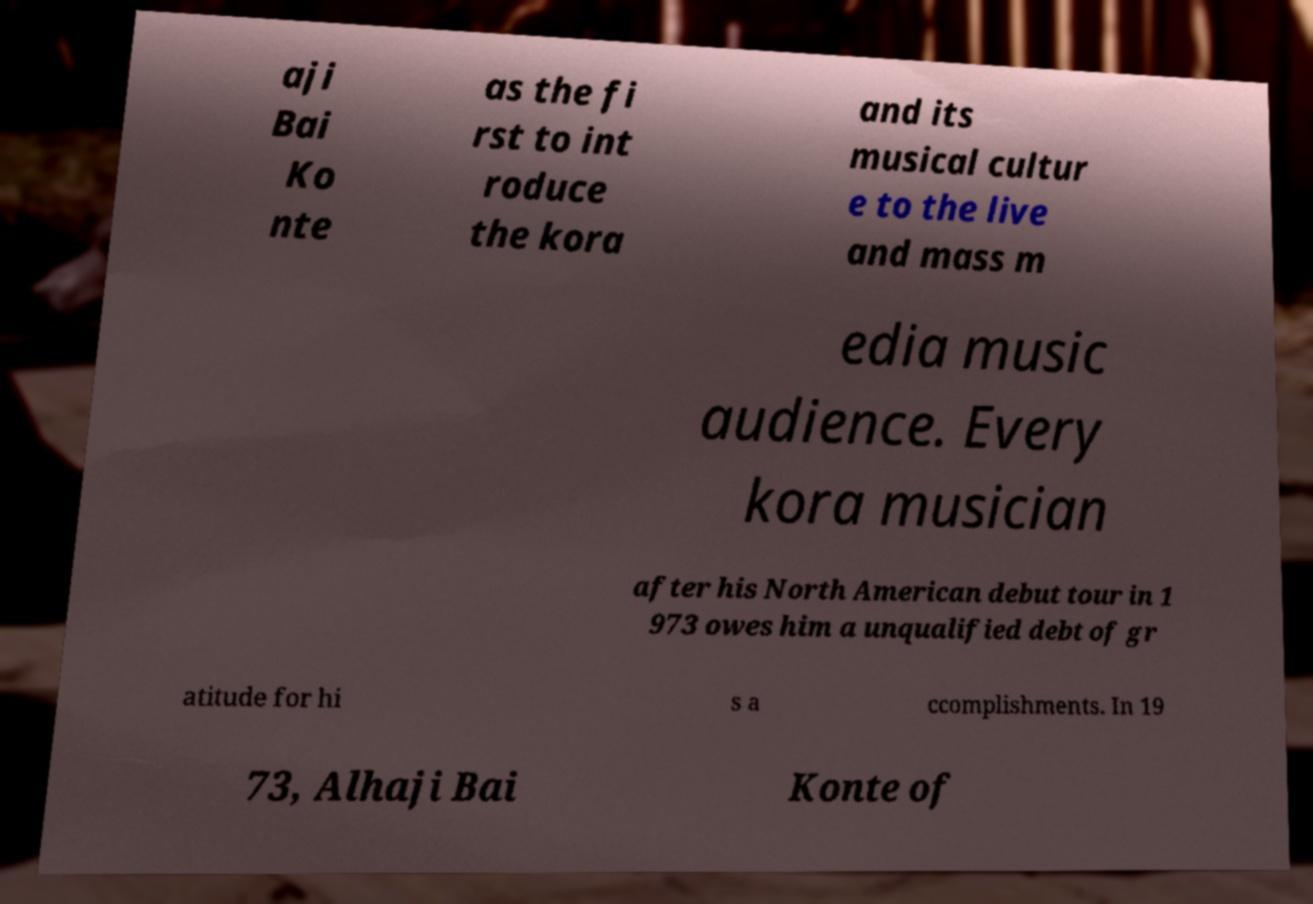What messages or text are displayed in this image? I need them in a readable, typed format. aji Bai Ko nte as the fi rst to int roduce the kora and its musical cultur e to the live and mass m edia music audience. Every kora musician after his North American debut tour in 1 973 owes him a unqualified debt of gr atitude for hi s a ccomplishments. In 19 73, Alhaji Bai Konte of 